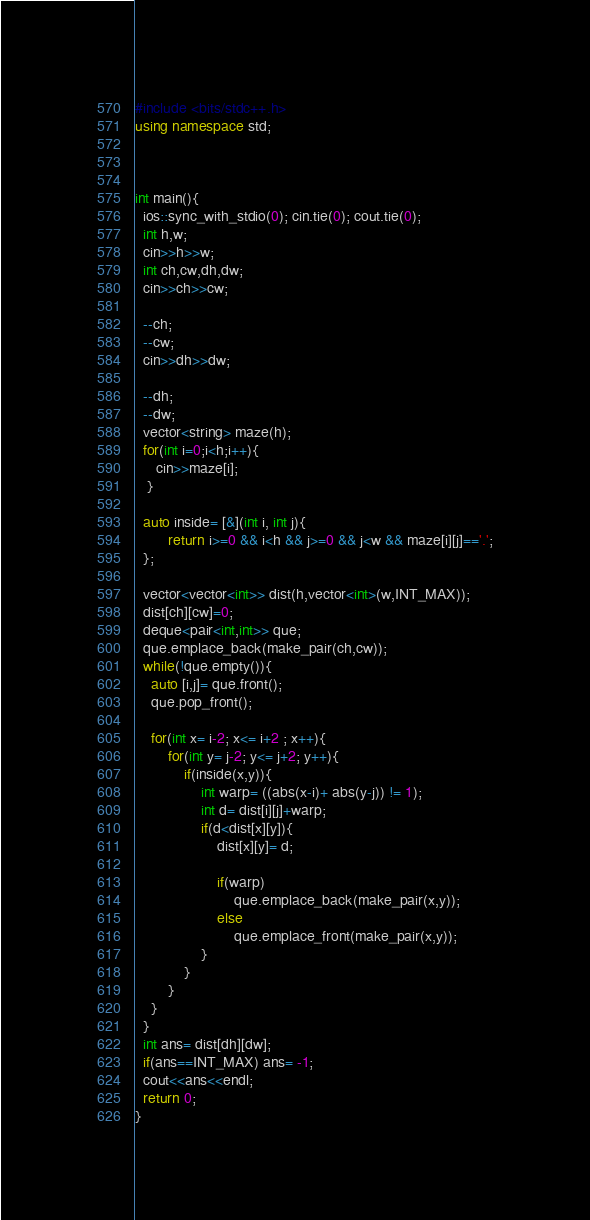Convert code to text. <code><loc_0><loc_0><loc_500><loc_500><_C++_>#include <bits/stdc++.h>
using namespace std;



int main(){
  ios::sync_with_stdio(0); cin.tie(0); cout.tie(0);
  int h,w;
  cin>>h>>w;
  int ch,cw,dh,dw;
  cin>>ch>>cw;

  --ch;
  --cw;
  cin>>dh>>dw;

  --dh;
  --dw;
  vector<string> maze(h);
  for(int i=0;i<h;i++){
     cin>>maze[i];
   }

  auto inside= [&](int i, int j){
        return i>=0 && i<h && j>=0 && j<w && maze[i][j]=='.';
  };

  vector<vector<int>> dist(h,vector<int>(w,INT_MAX));
  dist[ch][cw]=0;
  deque<pair<int,int>> que;
  que.emplace_back(make_pair(ch,cw));
  while(!que.empty()){
    auto [i,j]= que.front();
    que.pop_front();

    for(int x= i-2; x<= i+2 ; x++){
        for(int y= j-2; y<= j+2; y++){
            if(inside(x,y)){
                int warp= ((abs(x-i)+ abs(y-j)) != 1);
                int d= dist[i][j]+warp;
                if(d<dist[x][y]){
                    dist[x][y]= d;

                    if(warp)
                        que.emplace_back(make_pair(x,y));
                    else
                        que.emplace_front(make_pair(x,y));
                }
            }
        }
    }
  }
  int ans= dist[dh][dw];
  if(ans==INT_MAX) ans= -1;
  cout<<ans<<endl;
  return 0;
}
</code> 